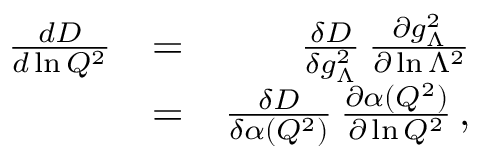<formula> <loc_0><loc_0><loc_500><loc_500>\begin{array} { r l r } { { \frac { d D } { d \ln Q ^ { 2 } } } } & { = } & { { \frac { \delta D } { \delta g _ { \Lambda } ^ { 2 } } } \, { \frac { \partial g _ { \Lambda } ^ { 2 } } { \partial \ln \Lambda ^ { 2 } } } } \\ & { = } & { { \frac { \delta D } { \delta \alpha ( Q ^ { 2 } ) } } \, { \frac { \partial \alpha ( Q ^ { 2 } ) } { \partial \ln Q ^ { 2 } } } \, , } \end{array}</formula> 